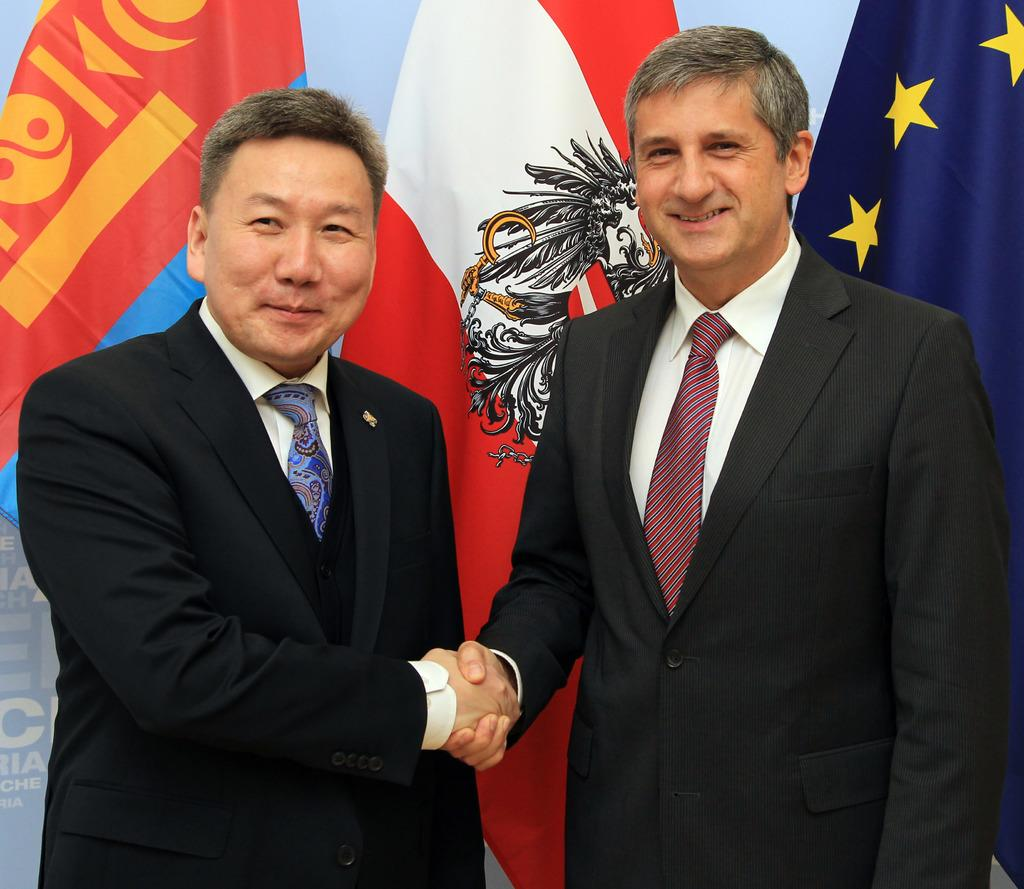What can be seen in the background of the image? There are flags in the background of the image. What are the men in the image wearing? The men are wearing blazers in the image. What are the men doing in the image? The men are shaking hands in the image. What expressions do the men have in the image? The men are smiling in the image. What type of bell can be heard ringing in the image? There is no bell present in the image, and therefore no sound can be heard. 